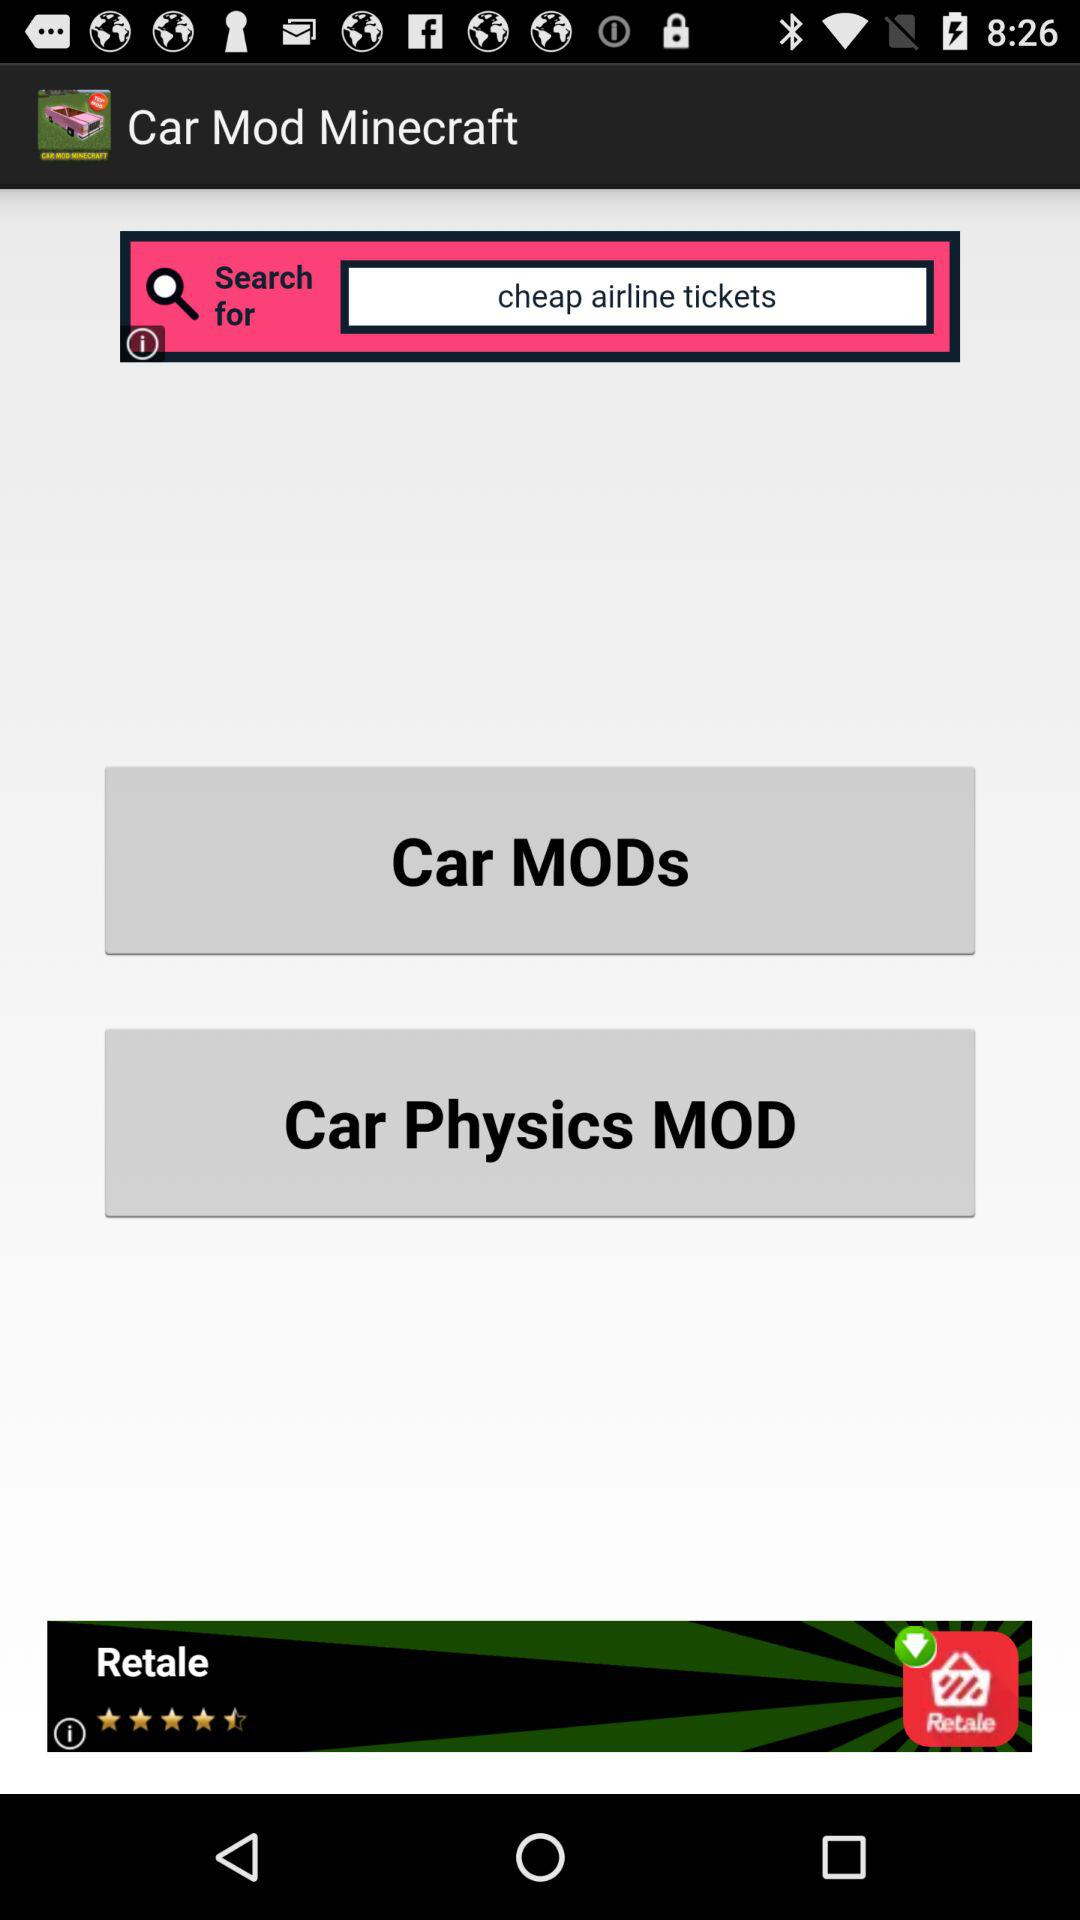What is the application name? The application name is "Car Mod Minecraft". 